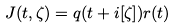Convert formula to latex. <formula><loc_0><loc_0><loc_500><loc_500>J ( t , \zeta ) = q ( t + i [ \zeta ] ) r ( t )</formula> 